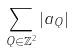Convert formula to latex. <formula><loc_0><loc_0><loc_500><loc_500>\sum _ { Q \in { \mathbb { Z } } ^ { 2 } } | a _ { Q } |</formula> 